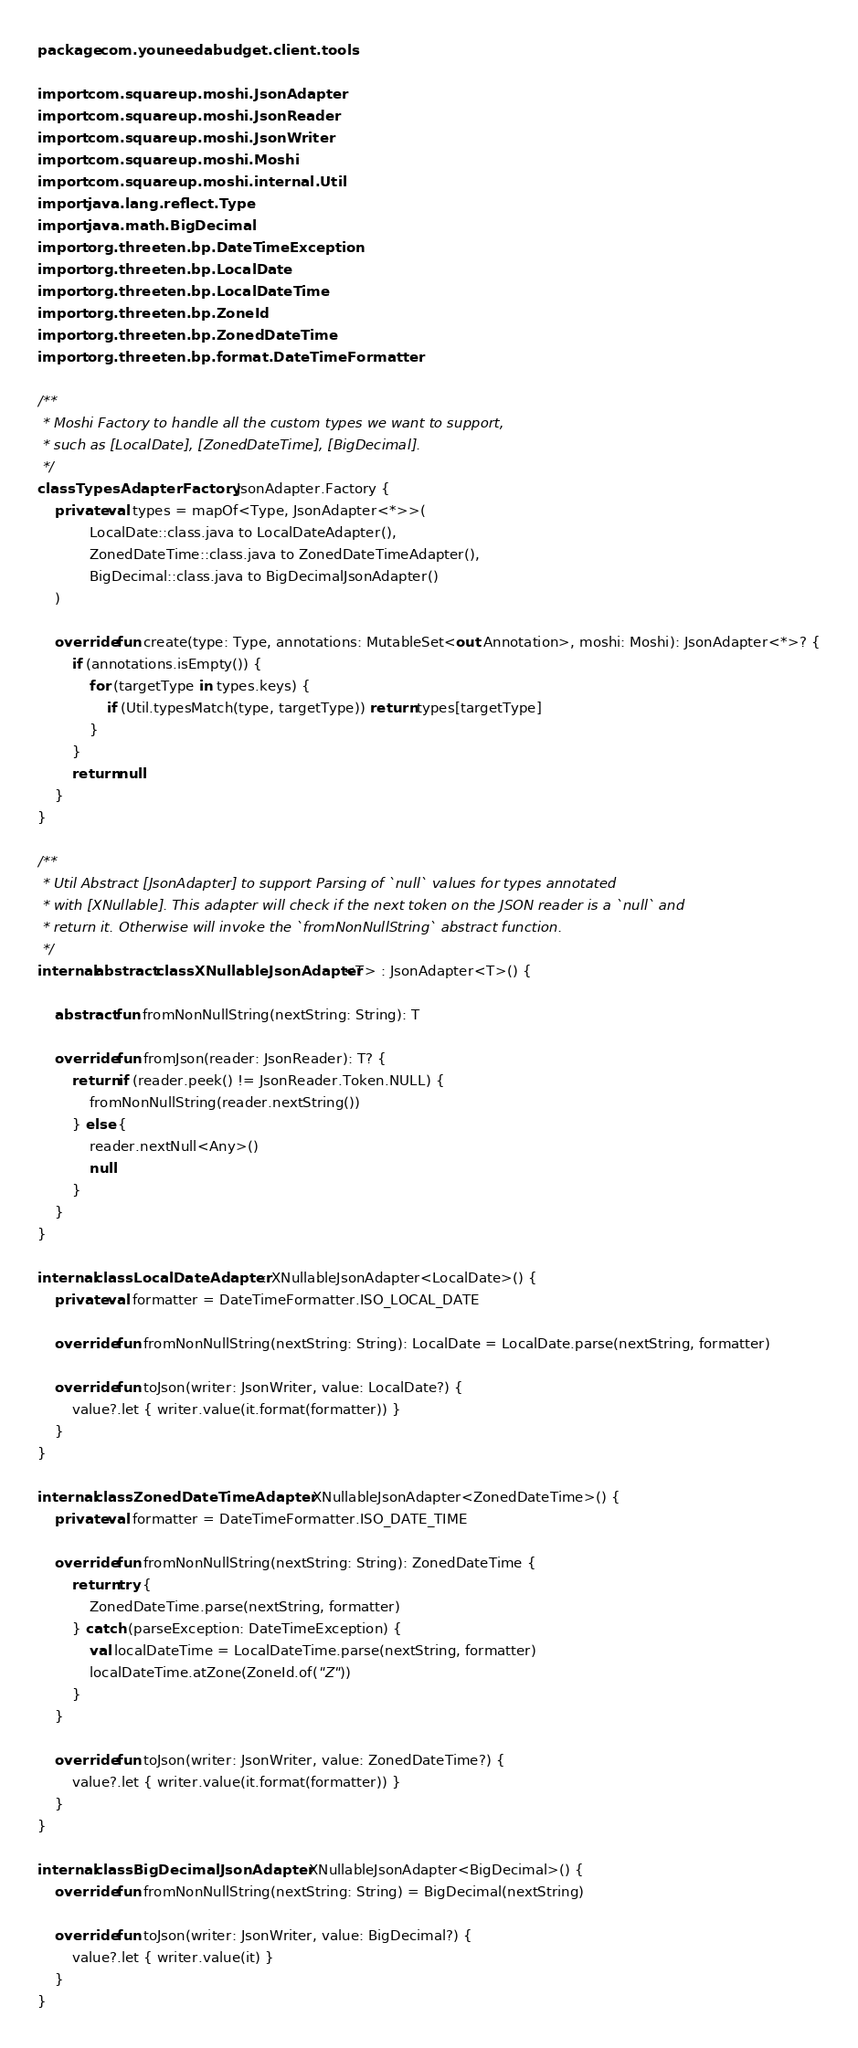<code> <loc_0><loc_0><loc_500><loc_500><_Kotlin_>package com.youneedabudget.client.tools

import com.squareup.moshi.JsonAdapter
import com.squareup.moshi.JsonReader
import com.squareup.moshi.JsonWriter
import com.squareup.moshi.Moshi
import com.squareup.moshi.internal.Util
import java.lang.reflect.Type
import java.math.BigDecimal
import org.threeten.bp.DateTimeException
import org.threeten.bp.LocalDate
import org.threeten.bp.LocalDateTime
import org.threeten.bp.ZoneId
import org.threeten.bp.ZonedDateTime
import org.threeten.bp.format.DateTimeFormatter

/**
 * Moshi Factory to handle all the custom types we want to support,
 * such as [LocalDate], [ZonedDateTime], [BigDecimal].
 */
class TypesAdapterFactory : JsonAdapter.Factory {
    private val types = mapOf<Type, JsonAdapter<*>>(
            LocalDate::class.java to LocalDateAdapter(),
            ZonedDateTime::class.java to ZonedDateTimeAdapter(),
            BigDecimal::class.java to BigDecimalJsonAdapter()
    )

    override fun create(type: Type, annotations: MutableSet<out Annotation>, moshi: Moshi): JsonAdapter<*>? {
        if (annotations.isEmpty()) {
            for (targetType in types.keys) {
                if (Util.typesMatch(type, targetType)) return types[targetType]
            }
        }
        return null
    }
}

/**
 * Util Abstract [JsonAdapter] to support Parsing of `null` values for types annotated
 * with [XNullable]. This adapter will check if the next token on the JSON reader is a `null` and
 * return it. Otherwise will invoke the `fromNonNullString` abstract function.
 */
internal abstract class XNullableJsonAdapter<T> : JsonAdapter<T>() {

    abstract fun fromNonNullString(nextString: String): T

    override fun fromJson(reader: JsonReader): T? {
        return if (reader.peek() != JsonReader.Token.NULL) {
            fromNonNullString(reader.nextString())
        } else {
            reader.nextNull<Any>()
            null
        }
    }
}

internal class LocalDateAdapter : XNullableJsonAdapter<LocalDate>() {
    private val formatter = DateTimeFormatter.ISO_LOCAL_DATE

    override fun fromNonNullString(nextString: String): LocalDate = LocalDate.parse(nextString, formatter)

    override fun toJson(writer: JsonWriter, value: LocalDate?) {
        value?.let { writer.value(it.format(formatter)) }
    }
}

internal class ZonedDateTimeAdapter : XNullableJsonAdapter<ZonedDateTime>() {
    private val formatter = DateTimeFormatter.ISO_DATE_TIME

    override fun fromNonNullString(nextString: String): ZonedDateTime {
        return try {
            ZonedDateTime.parse(nextString, formatter)
        } catch (parseException: DateTimeException) {
            val localDateTime = LocalDateTime.parse(nextString, formatter)
            localDateTime.atZone(ZoneId.of("Z"))
        }
    }

    override fun toJson(writer: JsonWriter, value: ZonedDateTime?) {
        value?.let { writer.value(it.format(formatter)) }
    }
}

internal class BigDecimalJsonAdapter : XNullableJsonAdapter<BigDecimal>() {
    override fun fromNonNullString(nextString: String) = BigDecimal(nextString)

    override fun toJson(writer: JsonWriter, value: BigDecimal?) {
        value?.let { writer.value(it) }
    }
}
</code> 